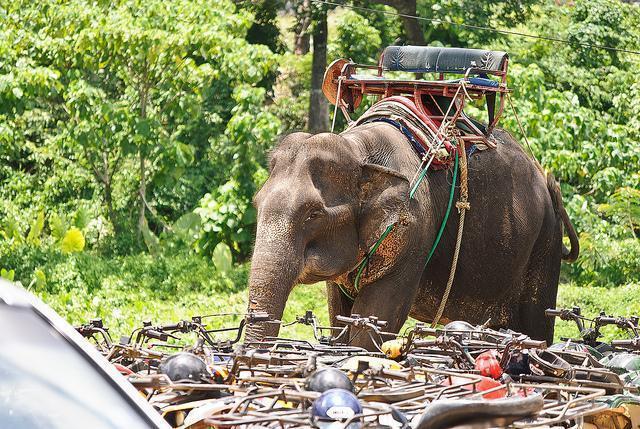What color is the back arch for the seat held by ropes on the back of this elephant?
Pick the correct solution from the four options below to address the question.
Options: Gold, blue, orange, green. Blue. 